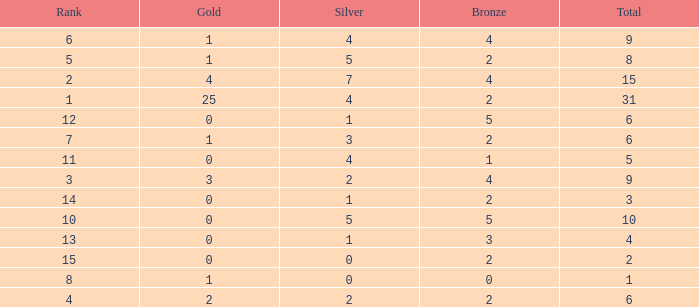What is the highest rank of the medal total less than 15, more than 2 bronzes, 0 gold and 1 silver? 13.0. 